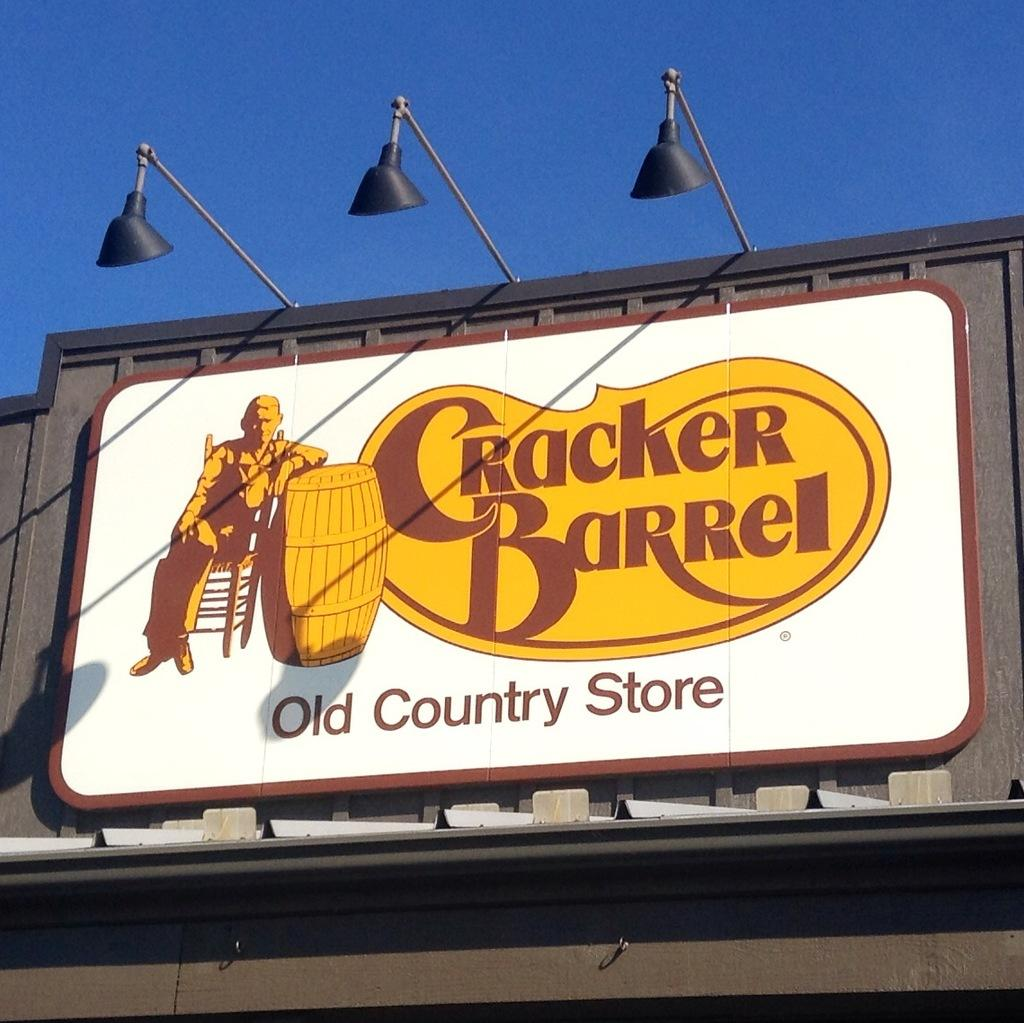What type of structure can be seen in the image? There is a wall in the image. What is attached to the wall in the image? There is a poster with text and images in the image. Who is present in the image? There are police officers in the image. What type of illumination is visible in the image? There are lights in the image. What can be seen in the background of the image? The sky is visible in the image. What type of cakes are being served to the police officers in the image? There are no cakes present in the image; it features a wall with a poster and police officers. How many sticks are being used by the police officers in the image? There are no sticks visible in the image; the police officers are not holding or using any sticks. 